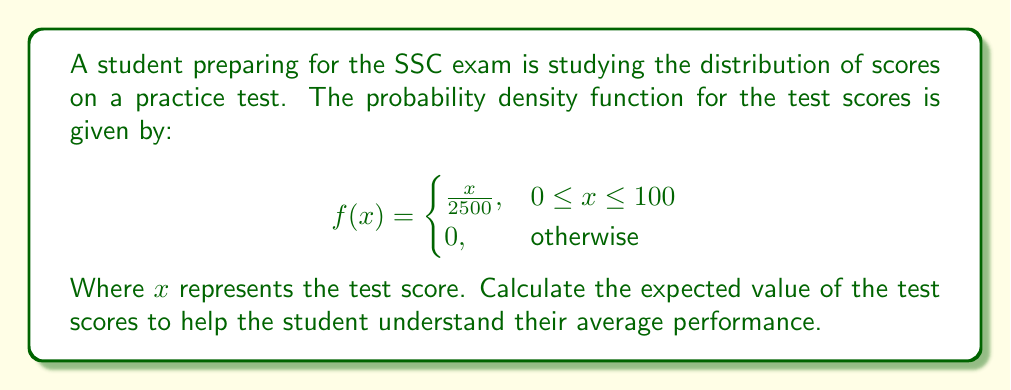Show me your answer to this math problem. To find the expected value of a continuous random variable, we use the formula:

$$E[X] = \int_{-\infty}^{\infty} x f(x) dx$$

In this case, our limits are from 0 to 100 as per the given function. So:

$$E[X] = \int_{0}^{100} x \cdot \frac{x}{2500} dx$$

Let's solve this step-by-step:

1) First, simplify the integrand:
   $$E[X] = \frac{1}{2500} \int_{0}^{100} x^2 dx$$

2) Integrate:
   $$E[X] = \frac{1}{2500} \left[\frac{x^3}{3}\right]_{0}^{100}$$

3) Evaluate the integral:
   $$E[X] = \frac{1}{2500} \left(\frac{100^3}{3} - \frac{0^3}{3}\right)$$

4) Simplify:
   $$E[X] = \frac{1}{2500} \cdot \frac{1,000,000}{3} = \frac{400}{3} \approx 66.67$$

Therefore, the expected value of the test scores is $\frac{400}{3}$ or approximately 66.67 points.
Answer: $\frac{400}{3}$ or approximately 66.67 